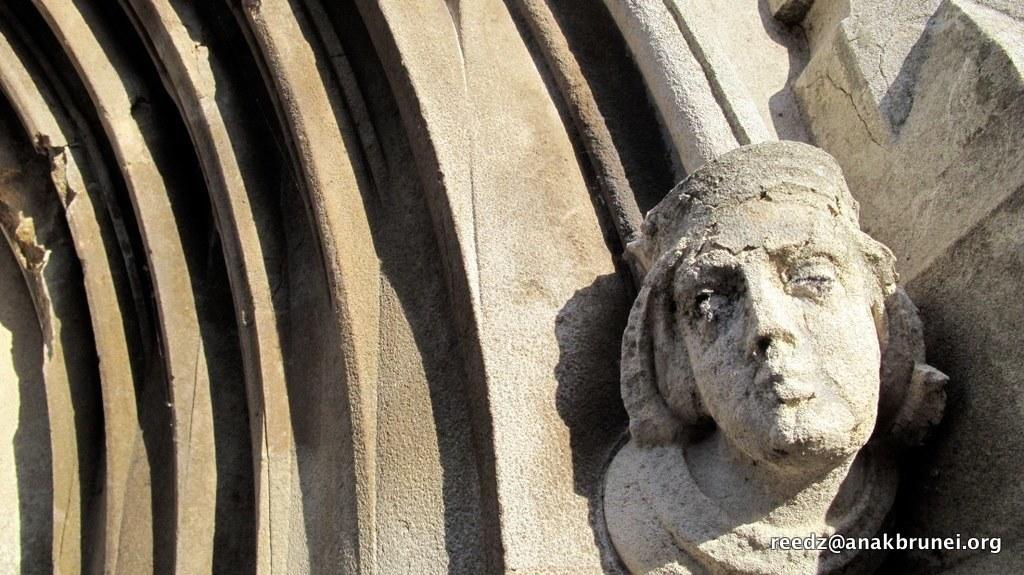What can be seen in the right corner of the image? There is a sculpture of a person's face in the right corner of the image. What is present in the left corner of the image? There is a designed wall in the left corner of the image. How does the potato contribute to the design of the wall in the image? There is no potato present in the image, so it cannot contribute to the design of the wall. 